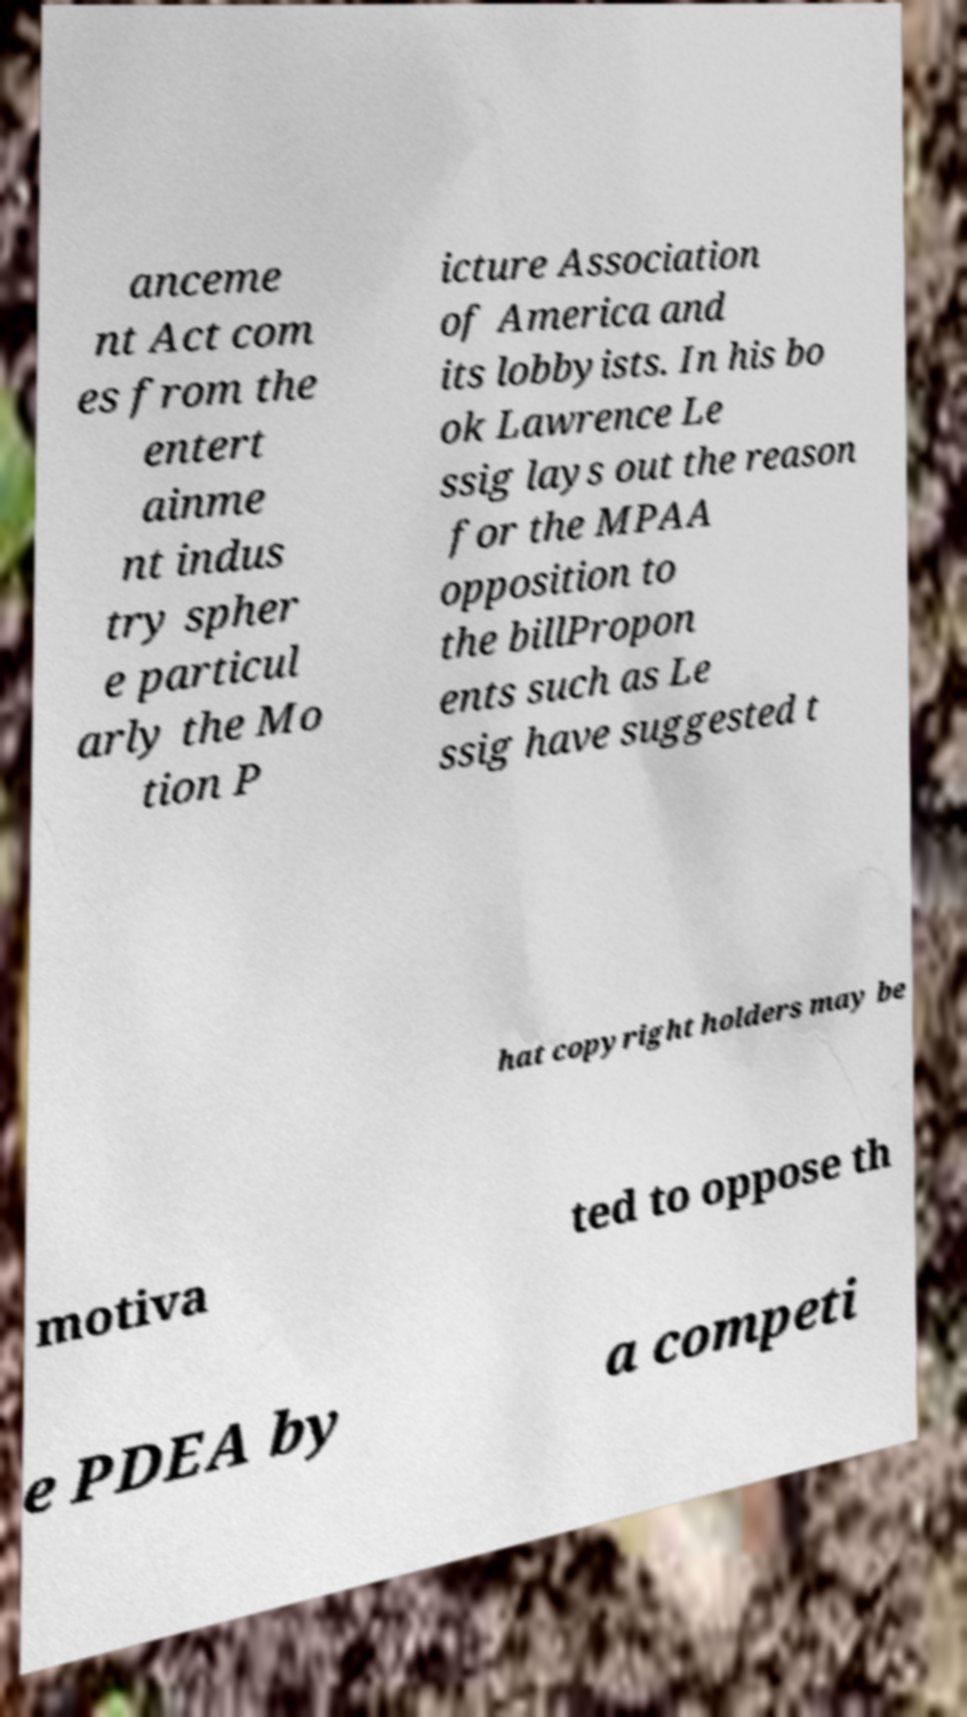Could you assist in decoding the text presented in this image and type it out clearly? anceme nt Act com es from the entert ainme nt indus try spher e particul arly the Mo tion P icture Association of America and its lobbyists. In his bo ok Lawrence Le ssig lays out the reason for the MPAA opposition to the billPropon ents such as Le ssig have suggested t hat copyright holders may be motiva ted to oppose th e PDEA by a competi 